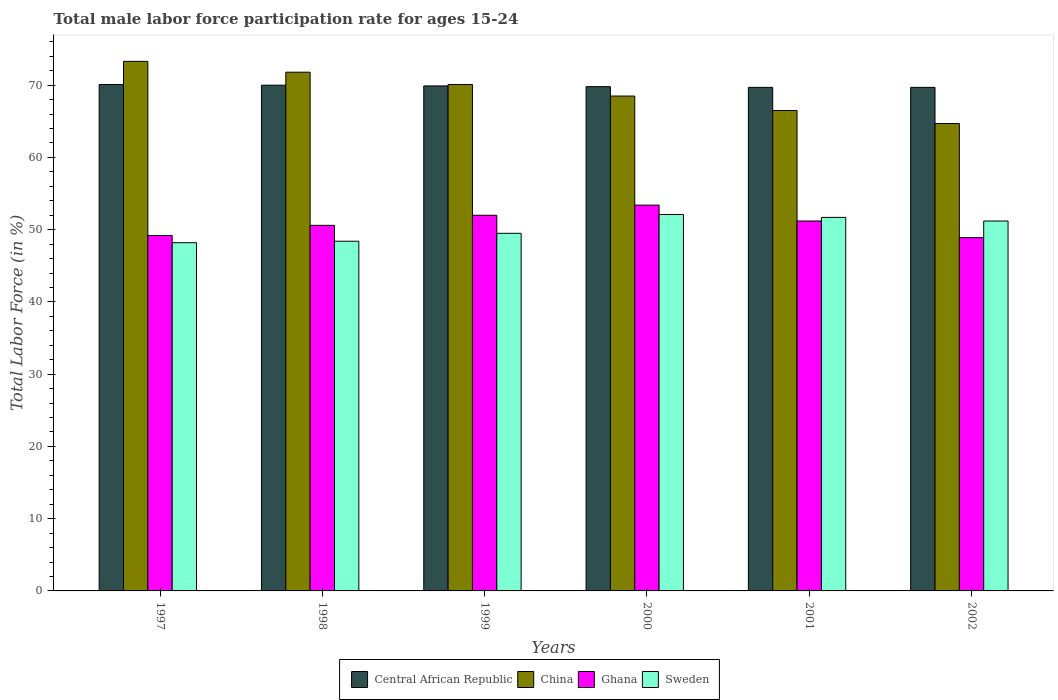In how many cases, is the number of bars for a given year not equal to the number of legend labels?
Keep it short and to the point. 0. What is the male labor force participation rate in Sweden in 2000?
Your answer should be very brief. 52.1. Across all years, what is the maximum male labor force participation rate in Central African Republic?
Keep it short and to the point. 70.1. Across all years, what is the minimum male labor force participation rate in Ghana?
Offer a very short reply. 48.9. In which year was the male labor force participation rate in Sweden minimum?
Provide a short and direct response. 1997. What is the total male labor force participation rate in Central African Republic in the graph?
Your response must be concise. 419.2. What is the difference between the male labor force participation rate in Sweden in 1998 and that in 2000?
Your answer should be compact. -3.7. What is the difference between the male labor force participation rate in Central African Republic in 1998 and the male labor force participation rate in China in 2002?
Offer a terse response. 5.3. What is the average male labor force participation rate in Ghana per year?
Give a very brief answer. 50.88. In the year 1997, what is the difference between the male labor force participation rate in Ghana and male labor force participation rate in Central African Republic?
Ensure brevity in your answer.  -20.9. What is the ratio of the male labor force participation rate in Central African Republic in 1998 to that in 2000?
Your answer should be very brief. 1. Is the male labor force participation rate in China in 1999 less than that in 2002?
Ensure brevity in your answer.  No. Is the difference between the male labor force participation rate in Ghana in 1999 and 2001 greater than the difference between the male labor force participation rate in Central African Republic in 1999 and 2001?
Offer a terse response. Yes. What is the difference between the highest and the second highest male labor force participation rate in Ghana?
Your answer should be very brief. 1.4. What is the difference between the highest and the lowest male labor force participation rate in Sweden?
Offer a very short reply. 3.9. In how many years, is the male labor force participation rate in Central African Republic greater than the average male labor force participation rate in Central African Republic taken over all years?
Keep it short and to the point. 3. What does the 3rd bar from the left in 1997 represents?
Give a very brief answer. Ghana. What does the 2nd bar from the right in 1999 represents?
Keep it short and to the point. Ghana. Is it the case that in every year, the sum of the male labor force participation rate in Ghana and male labor force participation rate in Central African Republic is greater than the male labor force participation rate in China?
Provide a succinct answer. Yes. How many bars are there?
Your answer should be very brief. 24. How many years are there in the graph?
Offer a very short reply. 6. Does the graph contain any zero values?
Provide a short and direct response. No. Where does the legend appear in the graph?
Make the answer very short. Bottom center. How are the legend labels stacked?
Provide a succinct answer. Horizontal. What is the title of the graph?
Provide a succinct answer. Total male labor force participation rate for ages 15-24. Does "Kazakhstan" appear as one of the legend labels in the graph?
Make the answer very short. No. What is the Total Labor Force (in %) of Central African Republic in 1997?
Make the answer very short. 70.1. What is the Total Labor Force (in %) of China in 1997?
Your answer should be compact. 73.3. What is the Total Labor Force (in %) of Ghana in 1997?
Offer a very short reply. 49.2. What is the Total Labor Force (in %) of Sweden in 1997?
Offer a very short reply. 48.2. What is the Total Labor Force (in %) in China in 1998?
Make the answer very short. 71.8. What is the Total Labor Force (in %) in Ghana in 1998?
Ensure brevity in your answer.  50.6. What is the Total Labor Force (in %) in Sweden in 1998?
Your answer should be very brief. 48.4. What is the Total Labor Force (in %) of Central African Republic in 1999?
Offer a terse response. 69.9. What is the Total Labor Force (in %) of China in 1999?
Offer a terse response. 70.1. What is the Total Labor Force (in %) in Sweden in 1999?
Provide a succinct answer. 49.5. What is the Total Labor Force (in %) in Central African Republic in 2000?
Your answer should be compact. 69.8. What is the Total Labor Force (in %) of China in 2000?
Give a very brief answer. 68.5. What is the Total Labor Force (in %) in Ghana in 2000?
Your answer should be very brief. 53.4. What is the Total Labor Force (in %) of Sweden in 2000?
Provide a short and direct response. 52.1. What is the Total Labor Force (in %) in Central African Republic in 2001?
Ensure brevity in your answer.  69.7. What is the Total Labor Force (in %) in China in 2001?
Offer a very short reply. 66.5. What is the Total Labor Force (in %) in Ghana in 2001?
Keep it short and to the point. 51.2. What is the Total Labor Force (in %) of Sweden in 2001?
Make the answer very short. 51.7. What is the Total Labor Force (in %) in Central African Republic in 2002?
Give a very brief answer. 69.7. What is the Total Labor Force (in %) of China in 2002?
Your response must be concise. 64.7. What is the Total Labor Force (in %) of Ghana in 2002?
Give a very brief answer. 48.9. What is the Total Labor Force (in %) of Sweden in 2002?
Provide a succinct answer. 51.2. Across all years, what is the maximum Total Labor Force (in %) in Central African Republic?
Provide a short and direct response. 70.1. Across all years, what is the maximum Total Labor Force (in %) in China?
Give a very brief answer. 73.3. Across all years, what is the maximum Total Labor Force (in %) of Ghana?
Your response must be concise. 53.4. Across all years, what is the maximum Total Labor Force (in %) in Sweden?
Make the answer very short. 52.1. Across all years, what is the minimum Total Labor Force (in %) in Central African Republic?
Provide a succinct answer. 69.7. Across all years, what is the minimum Total Labor Force (in %) of China?
Give a very brief answer. 64.7. Across all years, what is the minimum Total Labor Force (in %) in Ghana?
Provide a succinct answer. 48.9. Across all years, what is the minimum Total Labor Force (in %) of Sweden?
Give a very brief answer. 48.2. What is the total Total Labor Force (in %) in Central African Republic in the graph?
Provide a short and direct response. 419.2. What is the total Total Labor Force (in %) in China in the graph?
Keep it short and to the point. 414.9. What is the total Total Labor Force (in %) in Ghana in the graph?
Provide a succinct answer. 305.3. What is the total Total Labor Force (in %) in Sweden in the graph?
Your answer should be very brief. 301.1. What is the difference between the Total Labor Force (in %) in China in 1997 and that in 1998?
Give a very brief answer. 1.5. What is the difference between the Total Labor Force (in %) of China in 1997 and that in 2000?
Keep it short and to the point. 4.8. What is the difference between the Total Labor Force (in %) of Ghana in 1997 and that in 2000?
Your response must be concise. -4.2. What is the difference between the Total Labor Force (in %) in Central African Republic in 1997 and that in 2001?
Provide a short and direct response. 0.4. What is the difference between the Total Labor Force (in %) in Sweden in 1997 and that in 2001?
Your answer should be very brief. -3.5. What is the difference between the Total Labor Force (in %) in Central African Republic in 1997 and that in 2002?
Provide a short and direct response. 0.4. What is the difference between the Total Labor Force (in %) in Sweden in 1997 and that in 2002?
Your answer should be very brief. -3. What is the difference between the Total Labor Force (in %) in Ghana in 1998 and that in 1999?
Keep it short and to the point. -1.4. What is the difference between the Total Labor Force (in %) in China in 1998 and that in 2000?
Provide a succinct answer. 3.3. What is the difference between the Total Labor Force (in %) in Ghana in 1998 and that in 2000?
Your answer should be very brief. -2.8. What is the difference between the Total Labor Force (in %) of Sweden in 1998 and that in 2000?
Keep it short and to the point. -3.7. What is the difference between the Total Labor Force (in %) of Central African Republic in 1998 and that in 2001?
Offer a very short reply. 0.3. What is the difference between the Total Labor Force (in %) of China in 1998 and that in 2001?
Provide a short and direct response. 5.3. What is the difference between the Total Labor Force (in %) of Ghana in 1998 and that in 2001?
Keep it short and to the point. -0.6. What is the difference between the Total Labor Force (in %) in Central African Republic in 1998 and that in 2002?
Offer a terse response. 0.3. What is the difference between the Total Labor Force (in %) of China in 1998 and that in 2002?
Provide a short and direct response. 7.1. What is the difference between the Total Labor Force (in %) in Ghana in 1998 and that in 2002?
Your answer should be compact. 1.7. What is the difference between the Total Labor Force (in %) of Sweden in 1998 and that in 2002?
Your answer should be very brief. -2.8. What is the difference between the Total Labor Force (in %) of Central African Republic in 1999 and that in 2000?
Ensure brevity in your answer.  0.1. What is the difference between the Total Labor Force (in %) of China in 1999 and that in 2000?
Provide a succinct answer. 1.6. What is the difference between the Total Labor Force (in %) of Central African Republic in 1999 and that in 2001?
Offer a terse response. 0.2. What is the difference between the Total Labor Force (in %) in China in 1999 and that in 2001?
Give a very brief answer. 3.6. What is the difference between the Total Labor Force (in %) in China in 1999 and that in 2002?
Your answer should be very brief. 5.4. What is the difference between the Total Labor Force (in %) in Sweden in 1999 and that in 2002?
Your response must be concise. -1.7. What is the difference between the Total Labor Force (in %) of Sweden in 2000 and that in 2002?
Your answer should be compact. 0.9. What is the difference between the Total Labor Force (in %) of Central African Republic in 2001 and that in 2002?
Offer a terse response. 0. What is the difference between the Total Labor Force (in %) of Sweden in 2001 and that in 2002?
Offer a terse response. 0.5. What is the difference between the Total Labor Force (in %) of Central African Republic in 1997 and the Total Labor Force (in %) of Ghana in 1998?
Offer a terse response. 19.5. What is the difference between the Total Labor Force (in %) of Central African Republic in 1997 and the Total Labor Force (in %) of Sweden in 1998?
Keep it short and to the point. 21.7. What is the difference between the Total Labor Force (in %) in China in 1997 and the Total Labor Force (in %) in Ghana in 1998?
Make the answer very short. 22.7. What is the difference between the Total Labor Force (in %) of China in 1997 and the Total Labor Force (in %) of Sweden in 1998?
Keep it short and to the point. 24.9. What is the difference between the Total Labor Force (in %) in Ghana in 1997 and the Total Labor Force (in %) in Sweden in 1998?
Provide a succinct answer. 0.8. What is the difference between the Total Labor Force (in %) in Central African Republic in 1997 and the Total Labor Force (in %) in Ghana in 1999?
Your response must be concise. 18.1. What is the difference between the Total Labor Force (in %) of Central African Republic in 1997 and the Total Labor Force (in %) of Sweden in 1999?
Ensure brevity in your answer.  20.6. What is the difference between the Total Labor Force (in %) of China in 1997 and the Total Labor Force (in %) of Ghana in 1999?
Ensure brevity in your answer.  21.3. What is the difference between the Total Labor Force (in %) in China in 1997 and the Total Labor Force (in %) in Sweden in 1999?
Your answer should be compact. 23.8. What is the difference between the Total Labor Force (in %) of China in 1997 and the Total Labor Force (in %) of Sweden in 2000?
Offer a very short reply. 21.2. What is the difference between the Total Labor Force (in %) of Ghana in 1997 and the Total Labor Force (in %) of Sweden in 2000?
Provide a short and direct response. -2.9. What is the difference between the Total Labor Force (in %) in Central African Republic in 1997 and the Total Labor Force (in %) in Ghana in 2001?
Offer a terse response. 18.9. What is the difference between the Total Labor Force (in %) of Central African Republic in 1997 and the Total Labor Force (in %) of Sweden in 2001?
Provide a short and direct response. 18.4. What is the difference between the Total Labor Force (in %) in China in 1997 and the Total Labor Force (in %) in Ghana in 2001?
Your answer should be compact. 22.1. What is the difference between the Total Labor Force (in %) of China in 1997 and the Total Labor Force (in %) of Sweden in 2001?
Make the answer very short. 21.6. What is the difference between the Total Labor Force (in %) of Ghana in 1997 and the Total Labor Force (in %) of Sweden in 2001?
Offer a very short reply. -2.5. What is the difference between the Total Labor Force (in %) in Central African Republic in 1997 and the Total Labor Force (in %) in Ghana in 2002?
Your response must be concise. 21.2. What is the difference between the Total Labor Force (in %) of Central African Republic in 1997 and the Total Labor Force (in %) of Sweden in 2002?
Offer a terse response. 18.9. What is the difference between the Total Labor Force (in %) in China in 1997 and the Total Labor Force (in %) in Ghana in 2002?
Your response must be concise. 24.4. What is the difference between the Total Labor Force (in %) in China in 1997 and the Total Labor Force (in %) in Sweden in 2002?
Your answer should be compact. 22.1. What is the difference between the Total Labor Force (in %) of Central African Republic in 1998 and the Total Labor Force (in %) of China in 1999?
Ensure brevity in your answer.  -0.1. What is the difference between the Total Labor Force (in %) of Central African Republic in 1998 and the Total Labor Force (in %) of Ghana in 1999?
Ensure brevity in your answer.  18. What is the difference between the Total Labor Force (in %) of Central African Republic in 1998 and the Total Labor Force (in %) of Sweden in 1999?
Your response must be concise. 20.5. What is the difference between the Total Labor Force (in %) in China in 1998 and the Total Labor Force (in %) in Ghana in 1999?
Provide a short and direct response. 19.8. What is the difference between the Total Labor Force (in %) in China in 1998 and the Total Labor Force (in %) in Sweden in 1999?
Provide a short and direct response. 22.3. What is the difference between the Total Labor Force (in %) of Ghana in 1998 and the Total Labor Force (in %) of Sweden in 1999?
Your answer should be compact. 1.1. What is the difference between the Total Labor Force (in %) in Central African Republic in 1998 and the Total Labor Force (in %) in China in 2000?
Ensure brevity in your answer.  1.5. What is the difference between the Total Labor Force (in %) in Central African Republic in 1998 and the Total Labor Force (in %) in Ghana in 2000?
Provide a succinct answer. 16.6. What is the difference between the Total Labor Force (in %) of Central African Republic in 1998 and the Total Labor Force (in %) of Sweden in 2000?
Make the answer very short. 17.9. What is the difference between the Total Labor Force (in %) in China in 1998 and the Total Labor Force (in %) in Ghana in 2000?
Provide a short and direct response. 18.4. What is the difference between the Total Labor Force (in %) of Central African Republic in 1998 and the Total Labor Force (in %) of China in 2001?
Offer a terse response. 3.5. What is the difference between the Total Labor Force (in %) in Central African Republic in 1998 and the Total Labor Force (in %) in Ghana in 2001?
Offer a very short reply. 18.8. What is the difference between the Total Labor Force (in %) in Central African Republic in 1998 and the Total Labor Force (in %) in Sweden in 2001?
Give a very brief answer. 18.3. What is the difference between the Total Labor Force (in %) in China in 1998 and the Total Labor Force (in %) in Ghana in 2001?
Your answer should be very brief. 20.6. What is the difference between the Total Labor Force (in %) in China in 1998 and the Total Labor Force (in %) in Sweden in 2001?
Your response must be concise. 20.1. What is the difference between the Total Labor Force (in %) of Central African Republic in 1998 and the Total Labor Force (in %) of Ghana in 2002?
Give a very brief answer. 21.1. What is the difference between the Total Labor Force (in %) of China in 1998 and the Total Labor Force (in %) of Ghana in 2002?
Keep it short and to the point. 22.9. What is the difference between the Total Labor Force (in %) in China in 1998 and the Total Labor Force (in %) in Sweden in 2002?
Ensure brevity in your answer.  20.6. What is the difference between the Total Labor Force (in %) of Central African Republic in 1999 and the Total Labor Force (in %) of China in 2000?
Your answer should be very brief. 1.4. What is the difference between the Total Labor Force (in %) in Central African Republic in 1999 and the Total Labor Force (in %) in Ghana in 2000?
Provide a succinct answer. 16.5. What is the difference between the Total Labor Force (in %) in Central African Republic in 1999 and the Total Labor Force (in %) in Sweden in 2000?
Your answer should be compact. 17.8. What is the difference between the Total Labor Force (in %) in China in 1999 and the Total Labor Force (in %) in Sweden in 2000?
Give a very brief answer. 18. What is the difference between the Total Labor Force (in %) of Ghana in 1999 and the Total Labor Force (in %) of Sweden in 2000?
Your response must be concise. -0.1. What is the difference between the Total Labor Force (in %) in Central African Republic in 1999 and the Total Labor Force (in %) in China in 2001?
Offer a terse response. 3.4. What is the difference between the Total Labor Force (in %) in Central African Republic in 1999 and the Total Labor Force (in %) in Ghana in 2001?
Your answer should be very brief. 18.7. What is the difference between the Total Labor Force (in %) of Central African Republic in 1999 and the Total Labor Force (in %) of Sweden in 2001?
Keep it short and to the point. 18.2. What is the difference between the Total Labor Force (in %) in Ghana in 1999 and the Total Labor Force (in %) in Sweden in 2001?
Ensure brevity in your answer.  0.3. What is the difference between the Total Labor Force (in %) in Central African Republic in 1999 and the Total Labor Force (in %) in Ghana in 2002?
Your response must be concise. 21. What is the difference between the Total Labor Force (in %) of Central African Republic in 1999 and the Total Labor Force (in %) of Sweden in 2002?
Your answer should be very brief. 18.7. What is the difference between the Total Labor Force (in %) in China in 1999 and the Total Labor Force (in %) in Ghana in 2002?
Provide a short and direct response. 21.2. What is the difference between the Total Labor Force (in %) of Ghana in 1999 and the Total Labor Force (in %) of Sweden in 2002?
Provide a succinct answer. 0.8. What is the difference between the Total Labor Force (in %) in Central African Republic in 2000 and the Total Labor Force (in %) in China in 2001?
Your answer should be very brief. 3.3. What is the difference between the Total Labor Force (in %) in Central African Republic in 2000 and the Total Labor Force (in %) in Ghana in 2001?
Provide a short and direct response. 18.6. What is the difference between the Total Labor Force (in %) in China in 2000 and the Total Labor Force (in %) in Ghana in 2001?
Offer a terse response. 17.3. What is the difference between the Total Labor Force (in %) of China in 2000 and the Total Labor Force (in %) of Sweden in 2001?
Keep it short and to the point. 16.8. What is the difference between the Total Labor Force (in %) of Central African Republic in 2000 and the Total Labor Force (in %) of China in 2002?
Ensure brevity in your answer.  5.1. What is the difference between the Total Labor Force (in %) of Central African Republic in 2000 and the Total Labor Force (in %) of Ghana in 2002?
Offer a very short reply. 20.9. What is the difference between the Total Labor Force (in %) of Central African Republic in 2000 and the Total Labor Force (in %) of Sweden in 2002?
Give a very brief answer. 18.6. What is the difference between the Total Labor Force (in %) in China in 2000 and the Total Labor Force (in %) in Ghana in 2002?
Keep it short and to the point. 19.6. What is the difference between the Total Labor Force (in %) in Ghana in 2000 and the Total Labor Force (in %) in Sweden in 2002?
Your response must be concise. 2.2. What is the difference between the Total Labor Force (in %) of Central African Republic in 2001 and the Total Labor Force (in %) of China in 2002?
Offer a terse response. 5. What is the difference between the Total Labor Force (in %) in Central African Republic in 2001 and the Total Labor Force (in %) in Ghana in 2002?
Your response must be concise. 20.8. What is the difference between the Total Labor Force (in %) in Central African Republic in 2001 and the Total Labor Force (in %) in Sweden in 2002?
Offer a terse response. 18.5. What is the difference between the Total Labor Force (in %) of China in 2001 and the Total Labor Force (in %) of Sweden in 2002?
Give a very brief answer. 15.3. What is the difference between the Total Labor Force (in %) in Ghana in 2001 and the Total Labor Force (in %) in Sweden in 2002?
Your answer should be compact. 0. What is the average Total Labor Force (in %) in Central African Republic per year?
Provide a short and direct response. 69.87. What is the average Total Labor Force (in %) in China per year?
Provide a short and direct response. 69.15. What is the average Total Labor Force (in %) in Ghana per year?
Your answer should be very brief. 50.88. What is the average Total Labor Force (in %) in Sweden per year?
Provide a short and direct response. 50.18. In the year 1997, what is the difference between the Total Labor Force (in %) in Central African Republic and Total Labor Force (in %) in China?
Make the answer very short. -3.2. In the year 1997, what is the difference between the Total Labor Force (in %) in Central African Republic and Total Labor Force (in %) in Ghana?
Your answer should be very brief. 20.9. In the year 1997, what is the difference between the Total Labor Force (in %) in Central African Republic and Total Labor Force (in %) in Sweden?
Give a very brief answer. 21.9. In the year 1997, what is the difference between the Total Labor Force (in %) in China and Total Labor Force (in %) in Ghana?
Make the answer very short. 24.1. In the year 1997, what is the difference between the Total Labor Force (in %) of China and Total Labor Force (in %) of Sweden?
Offer a terse response. 25.1. In the year 1997, what is the difference between the Total Labor Force (in %) of Ghana and Total Labor Force (in %) of Sweden?
Provide a short and direct response. 1. In the year 1998, what is the difference between the Total Labor Force (in %) of Central African Republic and Total Labor Force (in %) of China?
Offer a very short reply. -1.8. In the year 1998, what is the difference between the Total Labor Force (in %) of Central African Republic and Total Labor Force (in %) of Sweden?
Ensure brevity in your answer.  21.6. In the year 1998, what is the difference between the Total Labor Force (in %) in China and Total Labor Force (in %) in Ghana?
Ensure brevity in your answer.  21.2. In the year 1998, what is the difference between the Total Labor Force (in %) of China and Total Labor Force (in %) of Sweden?
Provide a succinct answer. 23.4. In the year 1999, what is the difference between the Total Labor Force (in %) of Central African Republic and Total Labor Force (in %) of Sweden?
Offer a terse response. 20.4. In the year 1999, what is the difference between the Total Labor Force (in %) of China and Total Labor Force (in %) of Sweden?
Give a very brief answer. 20.6. In the year 2000, what is the difference between the Total Labor Force (in %) of Central African Republic and Total Labor Force (in %) of China?
Give a very brief answer. 1.3. In the year 2000, what is the difference between the Total Labor Force (in %) in China and Total Labor Force (in %) in Ghana?
Offer a terse response. 15.1. In the year 2000, what is the difference between the Total Labor Force (in %) in China and Total Labor Force (in %) in Sweden?
Provide a short and direct response. 16.4. In the year 2001, what is the difference between the Total Labor Force (in %) in Central African Republic and Total Labor Force (in %) in China?
Offer a very short reply. 3.2. In the year 2001, what is the difference between the Total Labor Force (in %) in China and Total Labor Force (in %) in Sweden?
Keep it short and to the point. 14.8. In the year 2001, what is the difference between the Total Labor Force (in %) of Ghana and Total Labor Force (in %) of Sweden?
Give a very brief answer. -0.5. In the year 2002, what is the difference between the Total Labor Force (in %) of Central African Republic and Total Labor Force (in %) of Ghana?
Offer a terse response. 20.8. In the year 2002, what is the difference between the Total Labor Force (in %) of China and Total Labor Force (in %) of Sweden?
Your answer should be compact. 13.5. In the year 2002, what is the difference between the Total Labor Force (in %) of Ghana and Total Labor Force (in %) of Sweden?
Provide a short and direct response. -2.3. What is the ratio of the Total Labor Force (in %) of China in 1997 to that in 1998?
Offer a very short reply. 1.02. What is the ratio of the Total Labor Force (in %) in Ghana in 1997 to that in 1998?
Ensure brevity in your answer.  0.97. What is the ratio of the Total Labor Force (in %) of Central African Republic in 1997 to that in 1999?
Offer a very short reply. 1. What is the ratio of the Total Labor Force (in %) in China in 1997 to that in 1999?
Give a very brief answer. 1.05. What is the ratio of the Total Labor Force (in %) of Ghana in 1997 to that in 1999?
Your response must be concise. 0.95. What is the ratio of the Total Labor Force (in %) in Sweden in 1997 to that in 1999?
Provide a succinct answer. 0.97. What is the ratio of the Total Labor Force (in %) of Central African Republic in 1997 to that in 2000?
Your answer should be compact. 1. What is the ratio of the Total Labor Force (in %) in China in 1997 to that in 2000?
Give a very brief answer. 1.07. What is the ratio of the Total Labor Force (in %) in Ghana in 1997 to that in 2000?
Provide a succinct answer. 0.92. What is the ratio of the Total Labor Force (in %) of Sweden in 1997 to that in 2000?
Your answer should be very brief. 0.93. What is the ratio of the Total Labor Force (in %) of China in 1997 to that in 2001?
Give a very brief answer. 1.1. What is the ratio of the Total Labor Force (in %) of Ghana in 1997 to that in 2001?
Make the answer very short. 0.96. What is the ratio of the Total Labor Force (in %) in Sweden in 1997 to that in 2001?
Your answer should be very brief. 0.93. What is the ratio of the Total Labor Force (in %) in China in 1997 to that in 2002?
Offer a terse response. 1.13. What is the ratio of the Total Labor Force (in %) in Ghana in 1997 to that in 2002?
Your answer should be very brief. 1.01. What is the ratio of the Total Labor Force (in %) of Sweden in 1997 to that in 2002?
Your answer should be very brief. 0.94. What is the ratio of the Total Labor Force (in %) in Central African Republic in 1998 to that in 1999?
Make the answer very short. 1. What is the ratio of the Total Labor Force (in %) of China in 1998 to that in 1999?
Your answer should be compact. 1.02. What is the ratio of the Total Labor Force (in %) of Ghana in 1998 to that in 1999?
Your answer should be compact. 0.97. What is the ratio of the Total Labor Force (in %) of Sweden in 1998 to that in 1999?
Offer a terse response. 0.98. What is the ratio of the Total Labor Force (in %) in China in 1998 to that in 2000?
Keep it short and to the point. 1.05. What is the ratio of the Total Labor Force (in %) in Ghana in 1998 to that in 2000?
Your answer should be compact. 0.95. What is the ratio of the Total Labor Force (in %) in Sweden in 1998 to that in 2000?
Give a very brief answer. 0.93. What is the ratio of the Total Labor Force (in %) of China in 1998 to that in 2001?
Keep it short and to the point. 1.08. What is the ratio of the Total Labor Force (in %) in Ghana in 1998 to that in 2001?
Provide a succinct answer. 0.99. What is the ratio of the Total Labor Force (in %) of Sweden in 1998 to that in 2001?
Your answer should be compact. 0.94. What is the ratio of the Total Labor Force (in %) of China in 1998 to that in 2002?
Your answer should be very brief. 1.11. What is the ratio of the Total Labor Force (in %) of Ghana in 1998 to that in 2002?
Your answer should be very brief. 1.03. What is the ratio of the Total Labor Force (in %) of Sweden in 1998 to that in 2002?
Your answer should be very brief. 0.95. What is the ratio of the Total Labor Force (in %) in Central African Republic in 1999 to that in 2000?
Provide a short and direct response. 1. What is the ratio of the Total Labor Force (in %) of China in 1999 to that in 2000?
Provide a short and direct response. 1.02. What is the ratio of the Total Labor Force (in %) of Ghana in 1999 to that in 2000?
Provide a succinct answer. 0.97. What is the ratio of the Total Labor Force (in %) in Sweden in 1999 to that in 2000?
Your answer should be compact. 0.95. What is the ratio of the Total Labor Force (in %) of Central African Republic in 1999 to that in 2001?
Your answer should be compact. 1. What is the ratio of the Total Labor Force (in %) of China in 1999 to that in 2001?
Provide a short and direct response. 1.05. What is the ratio of the Total Labor Force (in %) in Ghana in 1999 to that in 2001?
Your answer should be very brief. 1.02. What is the ratio of the Total Labor Force (in %) in Sweden in 1999 to that in 2001?
Keep it short and to the point. 0.96. What is the ratio of the Total Labor Force (in %) of China in 1999 to that in 2002?
Provide a succinct answer. 1.08. What is the ratio of the Total Labor Force (in %) of Ghana in 1999 to that in 2002?
Provide a short and direct response. 1.06. What is the ratio of the Total Labor Force (in %) of Sweden in 1999 to that in 2002?
Ensure brevity in your answer.  0.97. What is the ratio of the Total Labor Force (in %) in Central African Republic in 2000 to that in 2001?
Provide a short and direct response. 1. What is the ratio of the Total Labor Force (in %) in China in 2000 to that in 2001?
Your answer should be compact. 1.03. What is the ratio of the Total Labor Force (in %) of Ghana in 2000 to that in 2001?
Your answer should be very brief. 1.04. What is the ratio of the Total Labor Force (in %) of Sweden in 2000 to that in 2001?
Keep it short and to the point. 1.01. What is the ratio of the Total Labor Force (in %) in China in 2000 to that in 2002?
Make the answer very short. 1.06. What is the ratio of the Total Labor Force (in %) of Ghana in 2000 to that in 2002?
Make the answer very short. 1.09. What is the ratio of the Total Labor Force (in %) in Sweden in 2000 to that in 2002?
Provide a short and direct response. 1.02. What is the ratio of the Total Labor Force (in %) of China in 2001 to that in 2002?
Keep it short and to the point. 1.03. What is the ratio of the Total Labor Force (in %) in Ghana in 2001 to that in 2002?
Ensure brevity in your answer.  1.05. What is the ratio of the Total Labor Force (in %) in Sweden in 2001 to that in 2002?
Provide a succinct answer. 1.01. What is the difference between the highest and the second highest Total Labor Force (in %) in Central African Republic?
Give a very brief answer. 0.1. What is the difference between the highest and the second highest Total Labor Force (in %) of China?
Give a very brief answer. 1.5. What is the difference between the highest and the lowest Total Labor Force (in %) in China?
Keep it short and to the point. 8.6. What is the difference between the highest and the lowest Total Labor Force (in %) of Ghana?
Ensure brevity in your answer.  4.5. What is the difference between the highest and the lowest Total Labor Force (in %) in Sweden?
Your response must be concise. 3.9. 